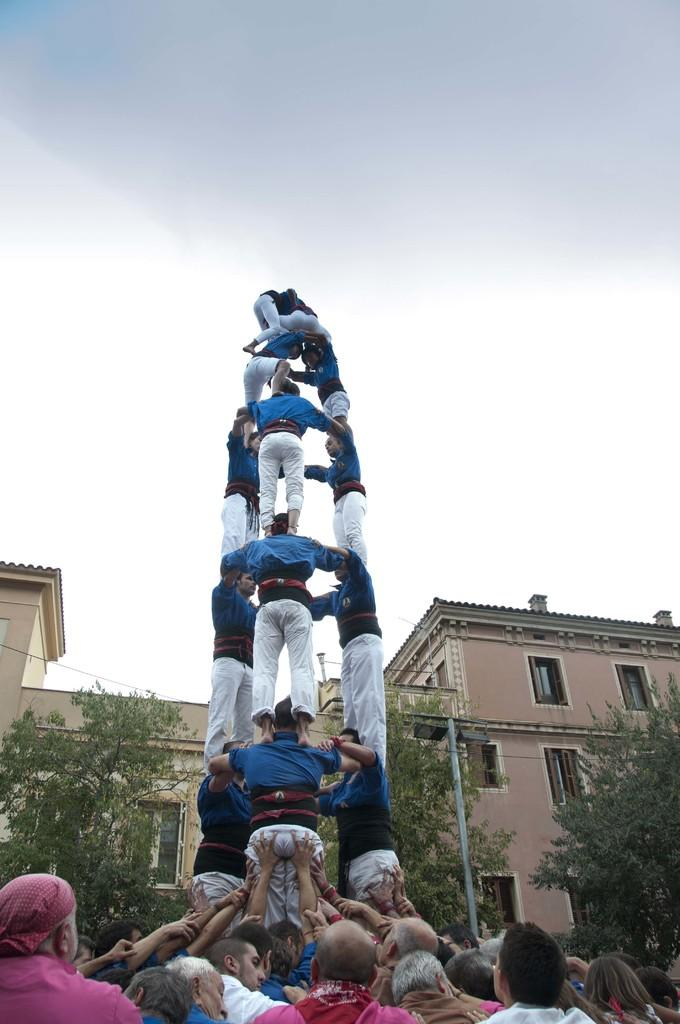What type of formation can be seen in the image? There is a human pyramid in the image. What type of natural elements are present in the image? There are trees in the image. What type of man-made structures are present in the image? There are houses in the image. What can be seen in the background of the image? The sky is visible in the background of the image. How many cakes are being held in the quiver by the person at the top of the pyramid? There are no cakes or quivers present in the image; it features a human pyramid, trees, houses, and the sky. 